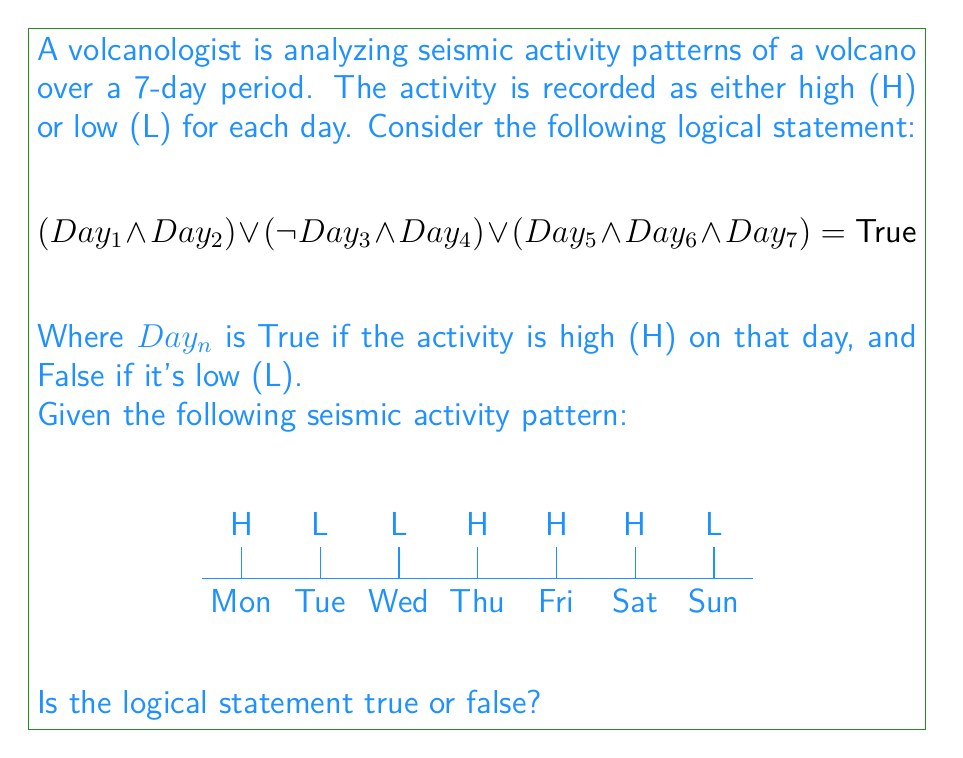Could you help me with this problem? Let's analyze this step-by-step:

1) First, let's assign truth values to each day based on the seismic activity:
   $Day_1 (Mon) = True$, $Day_2 (Tue) = False$, $Day_3 (Wed) = False$, 
   $Day_4 (Thu) = True$, $Day_5 (Fri) = True$, $Day_6 (Sat) = True$, $Day_7 (Sun) = False$

2) Now, let's evaluate each part of the logical statement:

   a) $(Day_1 \land Day_2)$:
      $True \land False = False$

   b) $(\neg Day_3 \land Day_4)$:
      $(\neg False \land True) = (True \land True) = True$

   c) $(Day_5 \land Day_6 \land Day_7)$:
      $True \land True \land False = False$

3) The full statement is the OR (∨) of these three parts:

   $False \lor True \lor False$

4) In Boolean logic, OR returns True if at least one of its operands is True.

5) Since we have at least one True (from part b), the entire statement evaluates to True.

Therefore, the logical statement is true for the given seismic activity pattern.
Answer: True 